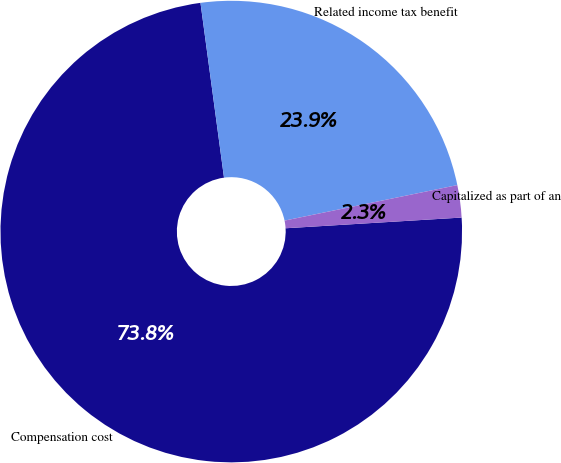Convert chart. <chart><loc_0><loc_0><loc_500><loc_500><pie_chart><fcel>Compensation cost<fcel>Related income tax benefit<fcel>Capitalized as part of an<nl><fcel>73.83%<fcel>23.9%<fcel>2.26%<nl></chart> 